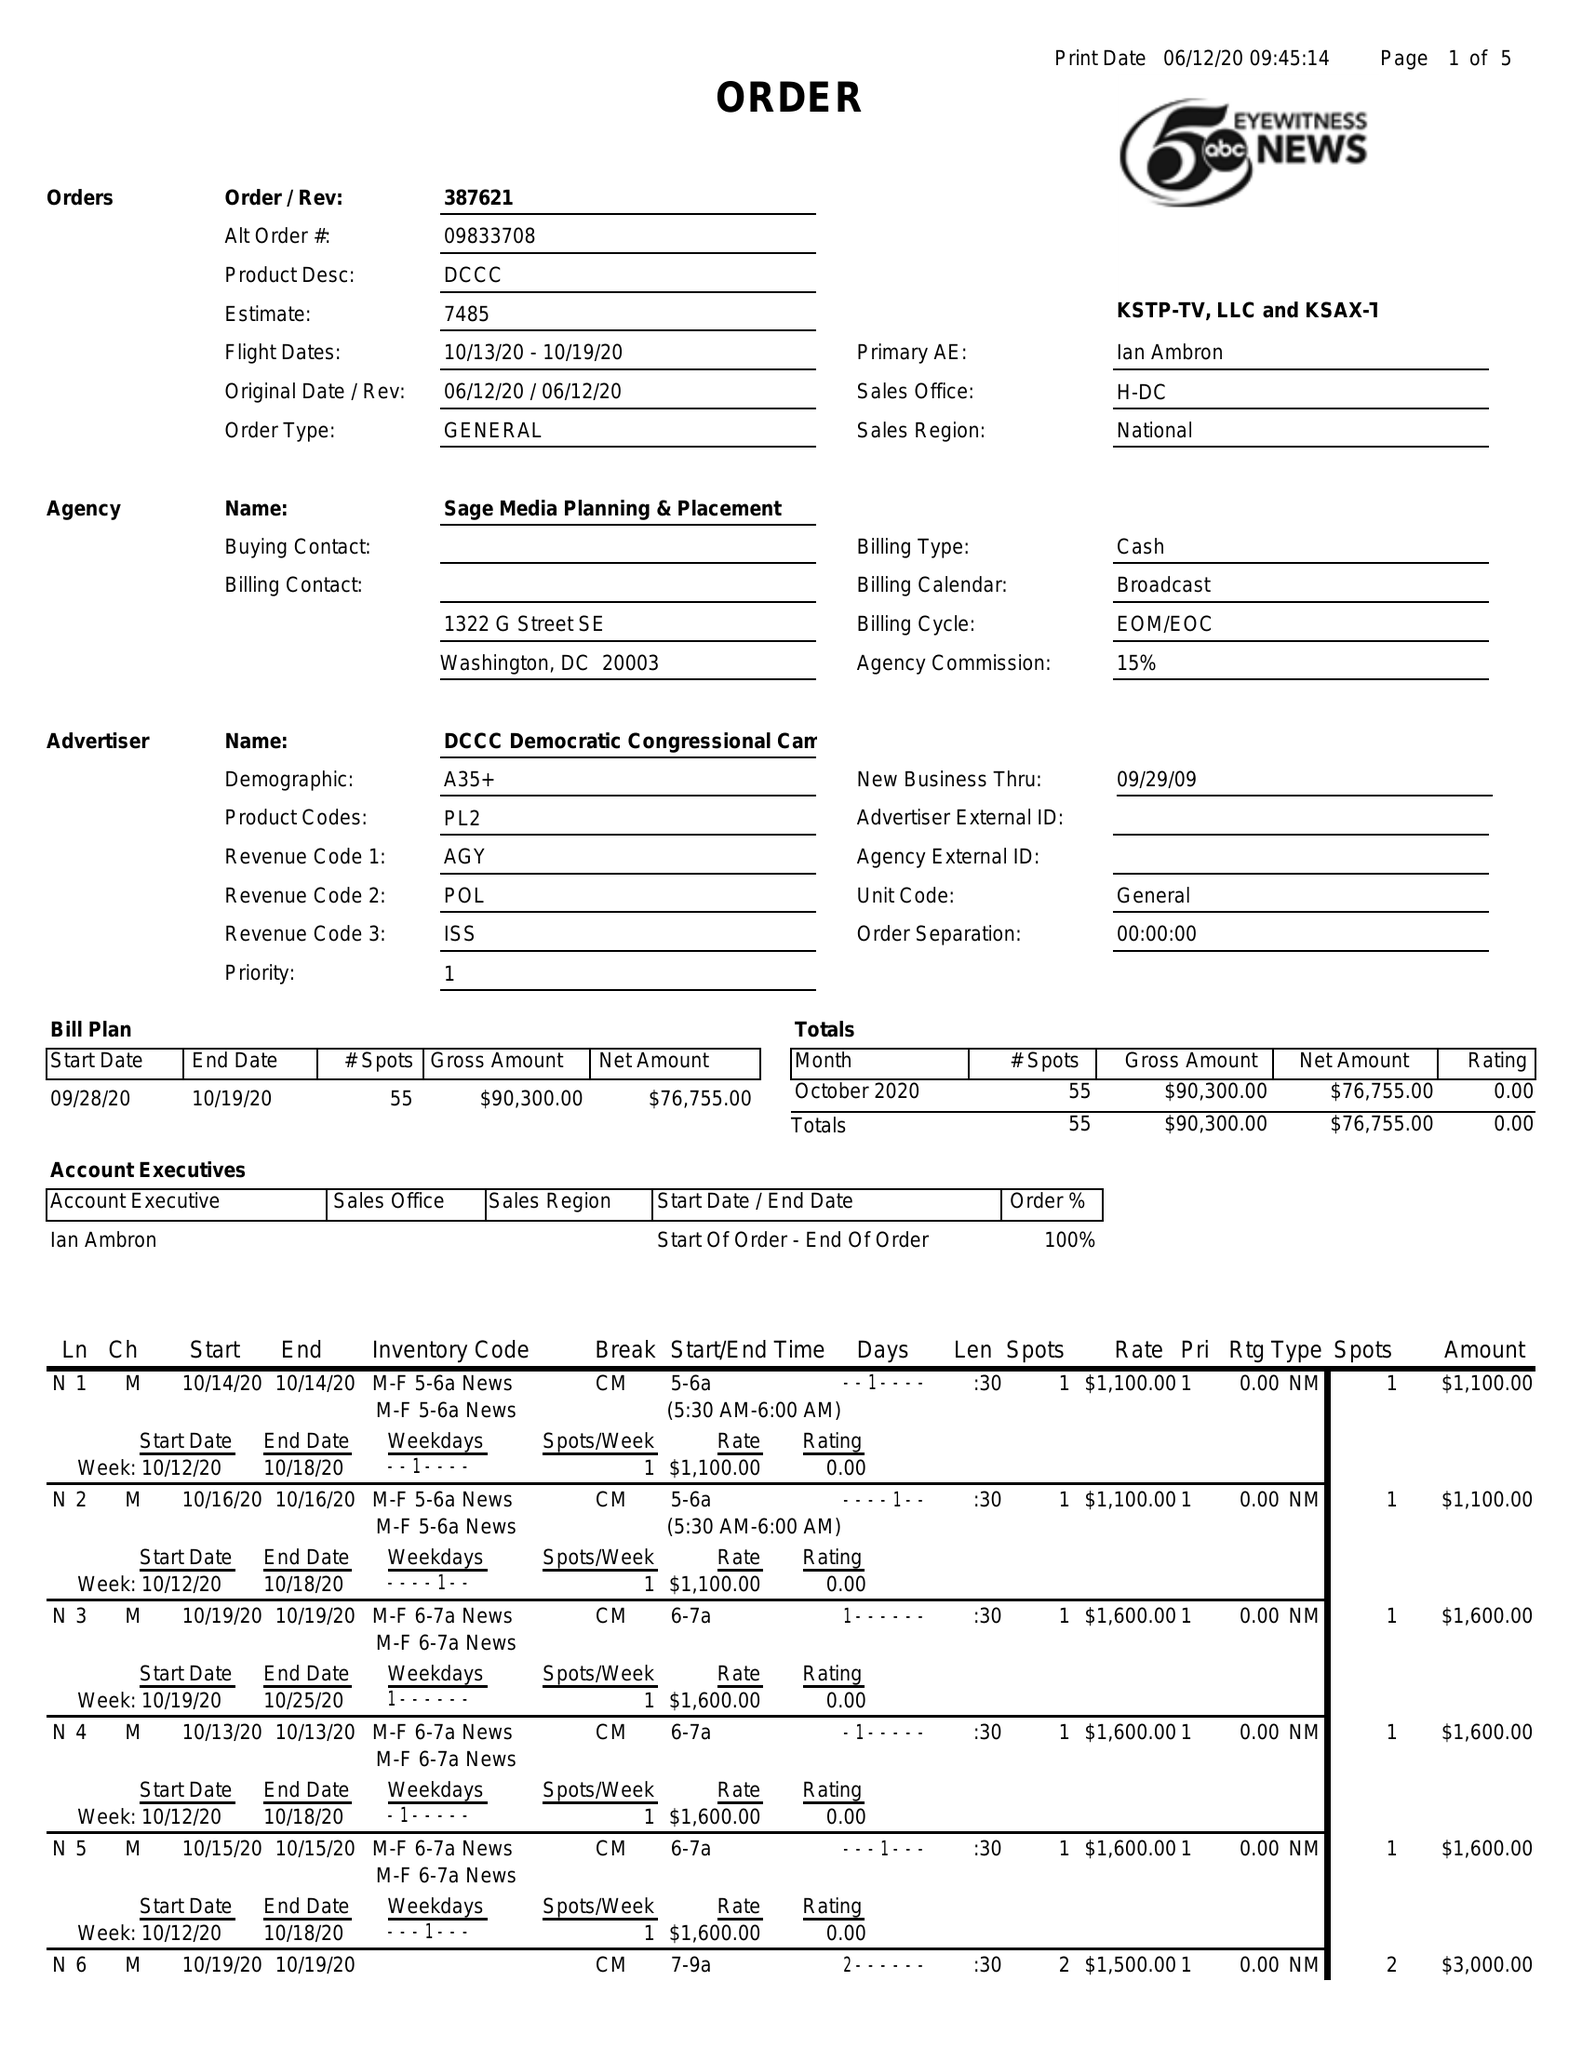What is the value for the gross_amount?
Answer the question using a single word or phrase. 90300.00 